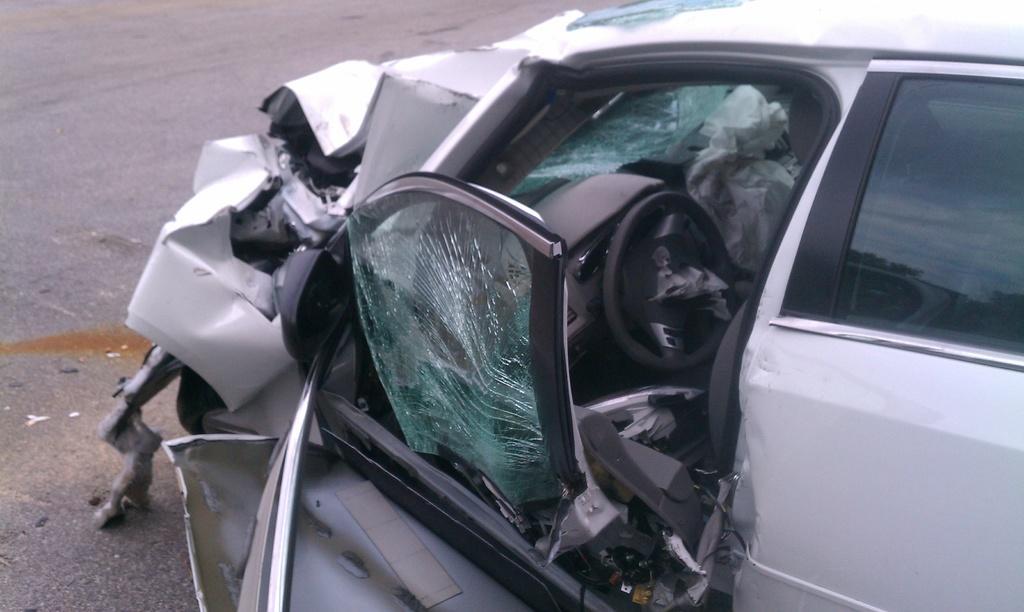Could you give a brief overview of what you see in this image? In this image I can see a damaged car on the road. The front part of the car is crushed. 